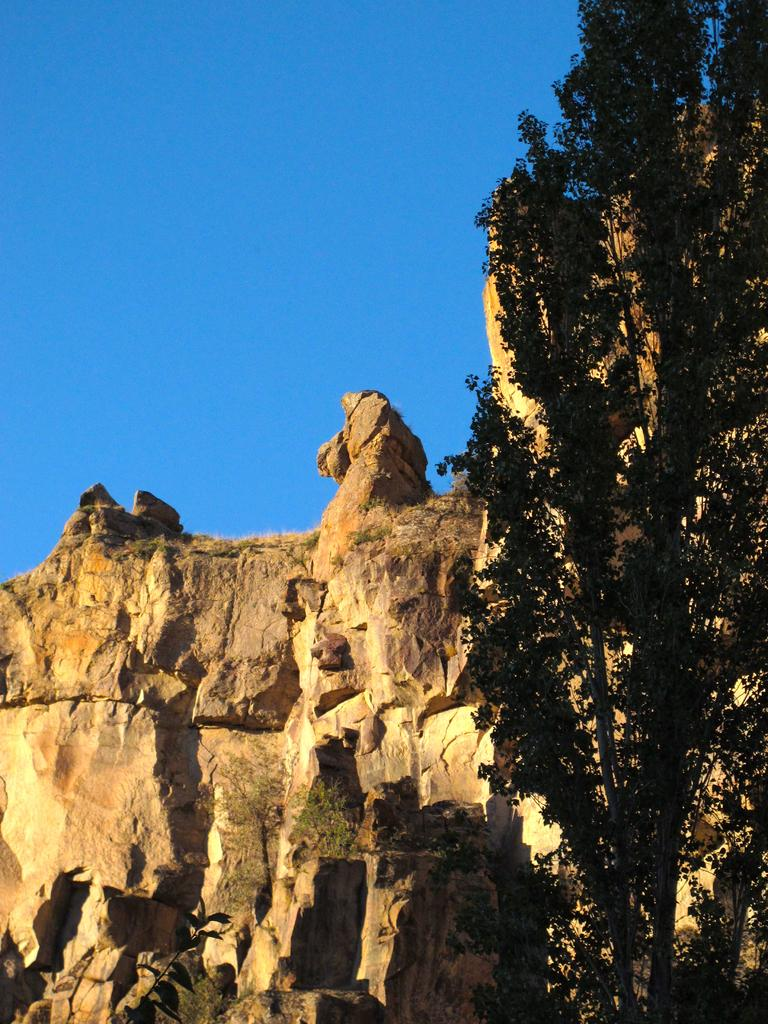What type of natural elements can be seen in the image? There are rocks and trees in the image. What can be seen in the background of the image? The sky is visible in the background of the image. What type of crime is being committed in the image? There is no crime present in the image; it features rocks, trees, and the sky. What type of building can be seen in the image? There is no building present in the image; it features rocks, trees, and the sky. 